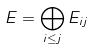Convert formula to latex. <formula><loc_0><loc_0><loc_500><loc_500>E = \bigoplus _ { i \leq j } E _ { i j }</formula> 